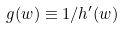Convert formula to latex. <formula><loc_0><loc_0><loc_500><loc_500>g ( w ) \equiv 1 / h ^ { \prime } ( w )</formula> 